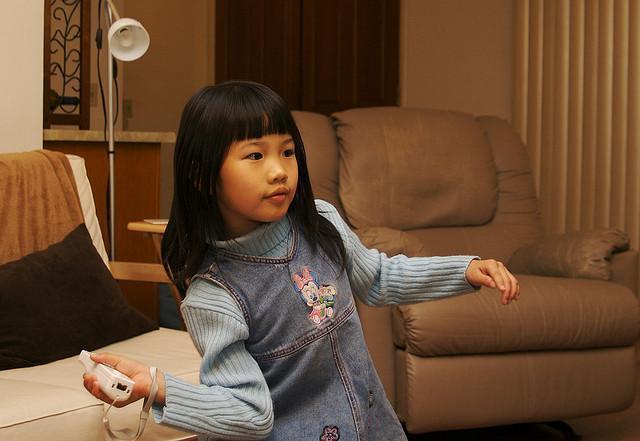How many cows are facing the camera?
Give a very brief answer. 0. 